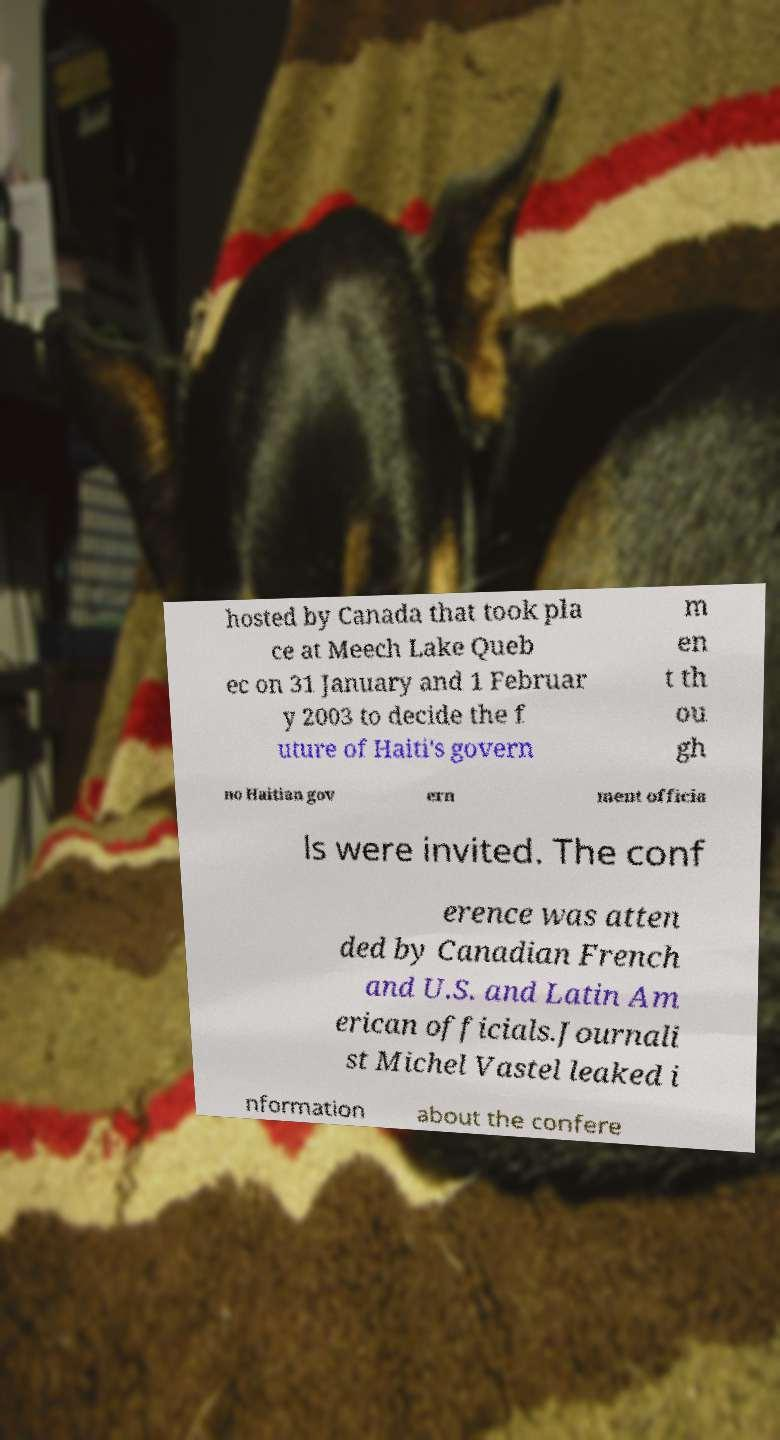Please identify and transcribe the text found in this image. hosted by Canada that took pla ce at Meech Lake Queb ec on 31 January and 1 Februar y 2003 to decide the f uture of Haiti's govern m en t th ou gh no Haitian gov ern ment officia ls were invited. The conf erence was atten ded by Canadian French and U.S. and Latin Am erican officials.Journali st Michel Vastel leaked i nformation about the confere 